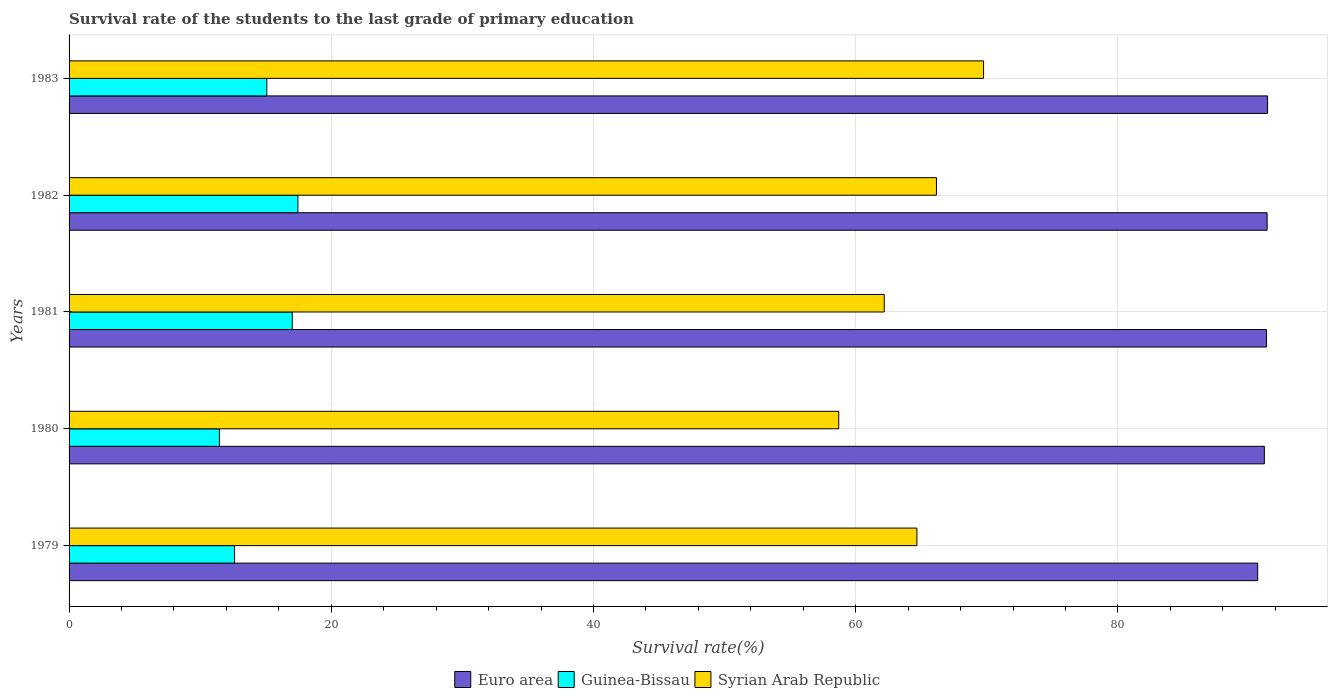How many different coloured bars are there?
Your answer should be compact. 3. How many groups of bars are there?
Provide a succinct answer. 5. How many bars are there on the 5th tick from the top?
Offer a terse response. 3. What is the label of the 3rd group of bars from the top?
Offer a very short reply. 1981. In how many cases, is the number of bars for a given year not equal to the number of legend labels?
Keep it short and to the point. 0. What is the survival rate of the students in Guinea-Bissau in 1981?
Make the answer very short. 17.02. Across all years, what is the maximum survival rate of the students in Guinea-Bissau?
Offer a very short reply. 17.45. Across all years, what is the minimum survival rate of the students in Euro area?
Make the answer very short. 90.66. In which year was the survival rate of the students in Euro area minimum?
Ensure brevity in your answer.  1979. What is the total survival rate of the students in Guinea-Bissau in the graph?
Provide a short and direct response. 73.65. What is the difference between the survival rate of the students in Syrian Arab Republic in 1981 and that in 1983?
Provide a succinct answer. -7.58. What is the difference between the survival rate of the students in Syrian Arab Republic in 1979 and the survival rate of the students in Guinea-Bissau in 1983?
Offer a terse response. 49.59. What is the average survival rate of the students in Syrian Arab Republic per year?
Provide a short and direct response. 64.29. In the year 1980, what is the difference between the survival rate of the students in Euro area and survival rate of the students in Syrian Arab Republic?
Your answer should be compact. 32.47. What is the ratio of the survival rate of the students in Euro area in 1979 to that in 1980?
Give a very brief answer. 0.99. Is the survival rate of the students in Syrian Arab Republic in 1980 less than that in 1983?
Keep it short and to the point. Yes. What is the difference between the highest and the second highest survival rate of the students in Euro area?
Offer a very short reply. 0.03. What is the difference between the highest and the lowest survival rate of the students in Guinea-Bissau?
Offer a terse response. 5.99. In how many years, is the survival rate of the students in Euro area greater than the average survival rate of the students in Euro area taken over all years?
Provide a succinct answer. 3. Is the sum of the survival rate of the students in Euro area in 1981 and 1983 greater than the maximum survival rate of the students in Syrian Arab Republic across all years?
Offer a very short reply. Yes. What does the 3rd bar from the bottom in 1982 represents?
Ensure brevity in your answer.  Syrian Arab Republic. How many bars are there?
Your response must be concise. 15. Does the graph contain any zero values?
Offer a very short reply. No. Does the graph contain grids?
Give a very brief answer. Yes. How many legend labels are there?
Offer a very short reply. 3. What is the title of the graph?
Give a very brief answer. Survival rate of the students to the last grade of primary education. What is the label or title of the X-axis?
Make the answer very short. Survival rate(%). What is the Survival rate(%) of Euro area in 1979?
Provide a short and direct response. 90.66. What is the Survival rate(%) of Guinea-Bissau in 1979?
Provide a short and direct response. 12.62. What is the Survival rate(%) of Syrian Arab Republic in 1979?
Give a very brief answer. 64.67. What is the Survival rate(%) in Euro area in 1980?
Give a very brief answer. 91.17. What is the Survival rate(%) in Guinea-Bissau in 1980?
Ensure brevity in your answer.  11.47. What is the Survival rate(%) of Syrian Arab Republic in 1980?
Your response must be concise. 58.71. What is the Survival rate(%) of Euro area in 1981?
Keep it short and to the point. 91.33. What is the Survival rate(%) in Guinea-Bissau in 1981?
Your answer should be very brief. 17.02. What is the Survival rate(%) of Syrian Arab Republic in 1981?
Ensure brevity in your answer.  62.18. What is the Survival rate(%) of Euro area in 1982?
Keep it short and to the point. 91.38. What is the Survival rate(%) in Guinea-Bissau in 1982?
Give a very brief answer. 17.45. What is the Survival rate(%) of Syrian Arab Republic in 1982?
Give a very brief answer. 66.16. What is the Survival rate(%) in Euro area in 1983?
Your answer should be compact. 91.42. What is the Survival rate(%) in Guinea-Bissau in 1983?
Ensure brevity in your answer.  15.08. What is the Survival rate(%) in Syrian Arab Republic in 1983?
Make the answer very short. 69.76. Across all years, what is the maximum Survival rate(%) in Euro area?
Give a very brief answer. 91.42. Across all years, what is the maximum Survival rate(%) in Guinea-Bissau?
Give a very brief answer. 17.45. Across all years, what is the maximum Survival rate(%) of Syrian Arab Republic?
Offer a terse response. 69.76. Across all years, what is the minimum Survival rate(%) in Euro area?
Give a very brief answer. 90.66. Across all years, what is the minimum Survival rate(%) of Guinea-Bissau?
Provide a short and direct response. 11.47. Across all years, what is the minimum Survival rate(%) in Syrian Arab Republic?
Ensure brevity in your answer.  58.71. What is the total Survival rate(%) of Euro area in the graph?
Ensure brevity in your answer.  455.97. What is the total Survival rate(%) of Guinea-Bissau in the graph?
Give a very brief answer. 73.65. What is the total Survival rate(%) of Syrian Arab Republic in the graph?
Provide a short and direct response. 321.47. What is the difference between the Survival rate(%) in Euro area in 1979 and that in 1980?
Provide a short and direct response. -0.51. What is the difference between the Survival rate(%) of Guinea-Bissau in 1979 and that in 1980?
Ensure brevity in your answer.  1.16. What is the difference between the Survival rate(%) in Syrian Arab Republic in 1979 and that in 1980?
Ensure brevity in your answer.  5.96. What is the difference between the Survival rate(%) of Euro area in 1979 and that in 1981?
Offer a terse response. -0.67. What is the difference between the Survival rate(%) in Guinea-Bissau in 1979 and that in 1981?
Make the answer very short. -4.4. What is the difference between the Survival rate(%) in Syrian Arab Republic in 1979 and that in 1981?
Your response must be concise. 2.49. What is the difference between the Survival rate(%) in Euro area in 1979 and that in 1982?
Make the answer very short. -0.72. What is the difference between the Survival rate(%) in Guinea-Bissau in 1979 and that in 1982?
Your answer should be very brief. -4.83. What is the difference between the Survival rate(%) of Syrian Arab Republic in 1979 and that in 1982?
Provide a short and direct response. -1.49. What is the difference between the Survival rate(%) in Euro area in 1979 and that in 1983?
Ensure brevity in your answer.  -0.75. What is the difference between the Survival rate(%) of Guinea-Bissau in 1979 and that in 1983?
Your response must be concise. -2.46. What is the difference between the Survival rate(%) of Syrian Arab Republic in 1979 and that in 1983?
Offer a very short reply. -5.08. What is the difference between the Survival rate(%) in Euro area in 1980 and that in 1981?
Your answer should be compact. -0.16. What is the difference between the Survival rate(%) of Guinea-Bissau in 1980 and that in 1981?
Offer a terse response. -5.55. What is the difference between the Survival rate(%) in Syrian Arab Republic in 1980 and that in 1981?
Your answer should be compact. -3.47. What is the difference between the Survival rate(%) in Euro area in 1980 and that in 1982?
Provide a short and direct response. -0.21. What is the difference between the Survival rate(%) of Guinea-Bissau in 1980 and that in 1982?
Offer a very short reply. -5.99. What is the difference between the Survival rate(%) of Syrian Arab Republic in 1980 and that in 1982?
Your answer should be very brief. -7.45. What is the difference between the Survival rate(%) of Euro area in 1980 and that in 1983?
Offer a terse response. -0.24. What is the difference between the Survival rate(%) of Guinea-Bissau in 1980 and that in 1983?
Your answer should be compact. -3.61. What is the difference between the Survival rate(%) in Syrian Arab Republic in 1980 and that in 1983?
Your answer should be compact. -11.05. What is the difference between the Survival rate(%) of Euro area in 1981 and that in 1982?
Keep it short and to the point. -0.05. What is the difference between the Survival rate(%) of Guinea-Bissau in 1981 and that in 1982?
Ensure brevity in your answer.  -0.43. What is the difference between the Survival rate(%) of Syrian Arab Republic in 1981 and that in 1982?
Your answer should be compact. -3.98. What is the difference between the Survival rate(%) in Euro area in 1981 and that in 1983?
Provide a short and direct response. -0.08. What is the difference between the Survival rate(%) of Guinea-Bissau in 1981 and that in 1983?
Provide a short and direct response. 1.94. What is the difference between the Survival rate(%) of Syrian Arab Republic in 1981 and that in 1983?
Provide a short and direct response. -7.58. What is the difference between the Survival rate(%) in Euro area in 1982 and that in 1983?
Your answer should be very brief. -0.03. What is the difference between the Survival rate(%) in Guinea-Bissau in 1982 and that in 1983?
Your response must be concise. 2.37. What is the difference between the Survival rate(%) in Syrian Arab Republic in 1982 and that in 1983?
Your response must be concise. -3.59. What is the difference between the Survival rate(%) in Euro area in 1979 and the Survival rate(%) in Guinea-Bissau in 1980?
Your answer should be compact. 79.2. What is the difference between the Survival rate(%) in Euro area in 1979 and the Survival rate(%) in Syrian Arab Republic in 1980?
Provide a succinct answer. 31.96. What is the difference between the Survival rate(%) in Guinea-Bissau in 1979 and the Survival rate(%) in Syrian Arab Republic in 1980?
Provide a succinct answer. -46.08. What is the difference between the Survival rate(%) of Euro area in 1979 and the Survival rate(%) of Guinea-Bissau in 1981?
Provide a succinct answer. 73.64. What is the difference between the Survival rate(%) of Euro area in 1979 and the Survival rate(%) of Syrian Arab Republic in 1981?
Provide a succinct answer. 28.49. What is the difference between the Survival rate(%) in Guinea-Bissau in 1979 and the Survival rate(%) in Syrian Arab Republic in 1981?
Provide a succinct answer. -49.55. What is the difference between the Survival rate(%) in Euro area in 1979 and the Survival rate(%) in Guinea-Bissau in 1982?
Keep it short and to the point. 73.21. What is the difference between the Survival rate(%) in Euro area in 1979 and the Survival rate(%) in Syrian Arab Republic in 1982?
Make the answer very short. 24.5. What is the difference between the Survival rate(%) in Guinea-Bissau in 1979 and the Survival rate(%) in Syrian Arab Republic in 1982?
Give a very brief answer. -53.54. What is the difference between the Survival rate(%) of Euro area in 1979 and the Survival rate(%) of Guinea-Bissau in 1983?
Keep it short and to the point. 75.58. What is the difference between the Survival rate(%) of Euro area in 1979 and the Survival rate(%) of Syrian Arab Republic in 1983?
Your answer should be compact. 20.91. What is the difference between the Survival rate(%) of Guinea-Bissau in 1979 and the Survival rate(%) of Syrian Arab Republic in 1983?
Your answer should be very brief. -57.13. What is the difference between the Survival rate(%) in Euro area in 1980 and the Survival rate(%) in Guinea-Bissau in 1981?
Provide a short and direct response. 74.15. What is the difference between the Survival rate(%) of Euro area in 1980 and the Survival rate(%) of Syrian Arab Republic in 1981?
Offer a very short reply. 29. What is the difference between the Survival rate(%) of Guinea-Bissau in 1980 and the Survival rate(%) of Syrian Arab Republic in 1981?
Offer a terse response. -50.71. What is the difference between the Survival rate(%) in Euro area in 1980 and the Survival rate(%) in Guinea-Bissau in 1982?
Keep it short and to the point. 73.72. What is the difference between the Survival rate(%) of Euro area in 1980 and the Survival rate(%) of Syrian Arab Republic in 1982?
Make the answer very short. 25.01. What is the difference between the Survival rate(%) in Guinea-Bissau in 1980 and the Survival rate(%) in Syrian Arab Republic in 1982?
Give a very brief answer. -54.69. What is the difference between the Survival rate(%) of Euro area in 1980 and the Survival rate(%) of Guinea-Bissau in 1983?
Offer a very short reply. 76.09. What is the difference between the Survival rate(%) in Euro area in 1980 and the Survival rate(%) in Syrian Arab Republic in 1983?
Ensure brevity in your answer.  21.42. What is the difference between the Survival rate(%) of Guinea-Bissau in 1980 and the Survival rate(%) of Syrian Arab Republic in 1983?
Provide a short and direct response. -58.29. What is the difference between the Survival rate(%) of Euro area in 1981 and the Survival rate(%) of Guinea-Bissau in 1982?
Give a very brief answer. 73.88. What is the difference between the Survival rate(%) in Euro area in 1981 and the Survival rate(%) in Syrian Arab Republic in 1982?
Your answer should be compact. 25.17. What is the difference between the Survival rate(%) in Guinea-Bissau in 1981 and the Survival rate(%) in Syrian Arab Republic in 1982?
Keep it short and to the point. -49.14. What is the difference between the Survival rate(%) in Euro area in 1981 and the Survival rate(%) in Guinea-Bissau in 1983?
Your answer should be very brief. 76.25. What is the difference between the Survival rate(%) in Euro area in 1981 and the Survival rate(%) in Syrian Arab Republic in 1983?
Offer a very short reply. 21.58. What is the difference between the Survival rate(%) in Guinea-Bissau in 1981 and the Survival rate(%) in Syrian Arab Republic in 1983?
Provide a short and direct response. -52.73. What is the difference between the Survival rate(%) in Euro area in 1982 and the Survival rate(%) in Guinea-Bissau in 1983?
Offer a terse response. 76.3. What is the difference between the Survival rate(%) in Euro area in 1982 and the Survival rate(%) in Syrian Arab Republic in 1983?
Provide a short and direct response. 21.63. What is the difference between the Survival rate(%) of Guinea-Bissau in 1982 and the Survival rate(%) of Syrian Arab Republic in 1983?
Your answer should be compact. -52.3. What is the average Survival rate(%) in Euro area per year?
Your answer should be very brief. 91.19. What is the average Survival rate(%) in Guinea-Bissau per year?
Your answer should be compact. 14.73. What is the average Survival rate(%) of Syrian Arab Republic per year?
Your answer should be very brief. 64.29. In the year 1979, what is the difference between the Survival rate(%) in Euro area and Survival rate(%) in Guinea-Bissau?
Keep it short and to the point. 78.04. In the year 1979, what is the difference between the Survival rate(%) in Euro area and Survival rate(%) in Syrian Arab Republic?
Your response must be concise. 25.99. In the year 1979, what is the difference between the Survival rate(%) in Guinea-Bissau and Survival rate(%) in Syrian Arab Republic?
Offer a terse response. -52.05. In the year 1980, what is the difference between the Survival rate(%) in Euro area and Survival rate(%) in Guinea-Bissau?
Ensure brevity in your answer.  79.7. In the year 1980, what is the difference between the Survival rate(%) of Euro area and Survival rate(%) of Syrian Arab Republic?
Keep it short and to the point. 32.47. In the year 1980, what is the difference between the Survival rate(%) of Guinea-Bissau and Survival rate(%) of Syrian Arab Republic?
Your answer should be very brief. -47.24. In the year 1981, what is the difference between the Survival rate(%) in Euro area and Survival rate(%) in Guinea-Bissau?
Make the answer very short. 74.31. In the year 1981, what is the difference between the Survival rate(%) of Euro area and Survival rate(%) of Syrian Arab Republic?
Make the answer very short. 29.16. In the year 1981, what is the difference between the Survival rate(%) in Guinea-Bissau and Survival rate(%) in Syrian Arab Republic?
Ensure brevity in your answer.  -45.15. In the year 1982, what is the difference between the Survival rate(%) in Euro area and Survival rate(%) in Guinea-Bissau?
Give a very brief answer. 73.93. In the year 1982, what is the difference between the Survival rate(%) of Euro area and Survival rate(%) of Syrian Arab Republic?
Make the answer very short. 25.22. In the year 1982, what is the difference between the Survival rate(%) in Guinea-Bissau and Survival rate(%) in Syrian Arab Republic?
Offer a terse response. -48.71. In the year 1983, what is the difference between the Survival rate(%) in Euro area and Survival rate(%) in Guinea-Bissau?
Give a very brief answer. 76.33. In the year 1983, what is the difference between the Survival rate(%) in Euro area and Survival rate(%) in Syrian Arab Republic?
Ensure brevity in your answer.  21.66. In the year 1983, what is the difference between the Survival rate(%) of Guinea-Bissau and Survival rate(%) of Syrian Arab Republic?
Your answer should be compact. -54.67. What is the ratio of the Survival rate(%) of Euro area in 1979 to that in 1980?
Provide a short and direct response. 0.99. What is the ratio of the Survival rate(%) in Guinea-Bissau in 1979 to that in 1980?
Provide a succinct answer. 1.1. What is the ratio of the Survival rate(%) in Syrian Arab Republic in 1979 to that in 1980?
Your response must be concise. 1.1. What is the ratio of the Survival rate(%) in Guinea-Bissau in 1979 to that in 1981?
Offer a terse response. 0.74. What is the ratio of the Survival rate(%) of Syrian Arab Republic in 1979 to that in 1981?
Offer a very short reply. 1.04. What is the ratio of the Survival rate(%) in Guinea-Bissau in 1979 to that in 1982?
Your answer should be compact. 0.72. What is the ratio of the Survival rate(%) in Syrian Arab Republic in 1979 to that in 1982?
Your response must be concise. 0.98. What is the ratio of the Survival rate(%) in Euro area in 1979 to that in 1983?
Provide a succinct answer. 0.99. What is the ratio of the Survival rate(%) of Guinea-Bissau in 1979 to that in 1983?
Provide a succinct answer. 0.84. What is the ratio of the Survival rate(%) in Syrian Arab Republic in 1979 to that in 1983?
Your answer should be very brief. 0.93. What is the ratio of the Survival rate(%) in Euro area in 1980 to that in 1981?
Your answer should be very brief. 1. What is the ratio of the Survival rate(%) in Guinea-Bissau in 1980 to that in 1981?
Your answer should be very brief. 0.67. What is the ratio of the Survival rate(%) of Syrian Arab Republic in 1980 to that in 1981?
Make the answer very short. 0.94. What is the ratio of the Survival rate(%) of Guinea-Bissau in 1980 to that in 1982?
Your answer should be compact. 0.66. What is the ratio of the Survival rate(%) in Syrian Arab Republic in 1980 to that in 1982?
Provide a succinct answer. 0.89. What is the ratio of the Survival rate(%) of Guinea-Bissau in 1980 to that in 1983?
Provide a short and direct response. 0.76. What is the ratio of the Survival rate(%) of Syrian Arab Republic in 1980 to that in 1983?
Provide a succinct answer. 0.84. What is the ratio of the Survival rate(%) of Euro area in 1981 to that in 1982?
Keep it short and to the point. 1. What is the ratio of the Survival rate(%) of Guinea-Bissau in 1981 to that in 1982?
Your answer should be compact. 0.98. What is the ratio of the Survival rate(%) of Syrian Arab Republic in 1981 to that in 1982?
Your answer should be very brief. 0.94. What is the ratio of the Survival rate(%) in Euro area in 1981 to that in 1983?
Provide a succinct answer. 1. What is the ratio of the Survival rate(%) in Guinea-Bissau in 1981 to that in 1983?
Provide a short and direct response. 1.13. What is the ratio of the Survival rate(%) in Syrian Arab Republic in 1981 to that in 1983?
Your response must be concise. 0.89. What is the ratio of the Survival rate(%) of Euro area in 1982 to that in 1983?
Give a very brief answer. 1. What is the ratio of the Survival rate(%) in Guinea-Bissau in 1982 to that in 1983?
Keep it short and to the point. 1.16. What is the ratio of the Survival rate(%) of Syrian Arab Republic in 1982 to that in 1983?
Keep it short and to the point. 0.95. What is the difference between the highest and the second highest Survival rate(%) of Guinea-Bissau?
Offer a very short reply. 0.43. What is the difference between the highest and the second highest Survival rate(%) in Syrian Arab Republic?
Make the answer very short. 3.59. What is the difference between the highest and the lowest Survival rate(%) of Euro area?
Provide a short and direct response. 0.75. What is the difference between the highest and the lowest Survival rate(%) in Guinea-Bissau?
Your answer should be very brief. 5.99. What is the difference between the highest and the lowest Survival rate(%) of Syrian Arab Republic?
Offer a terse response. 11.05. 